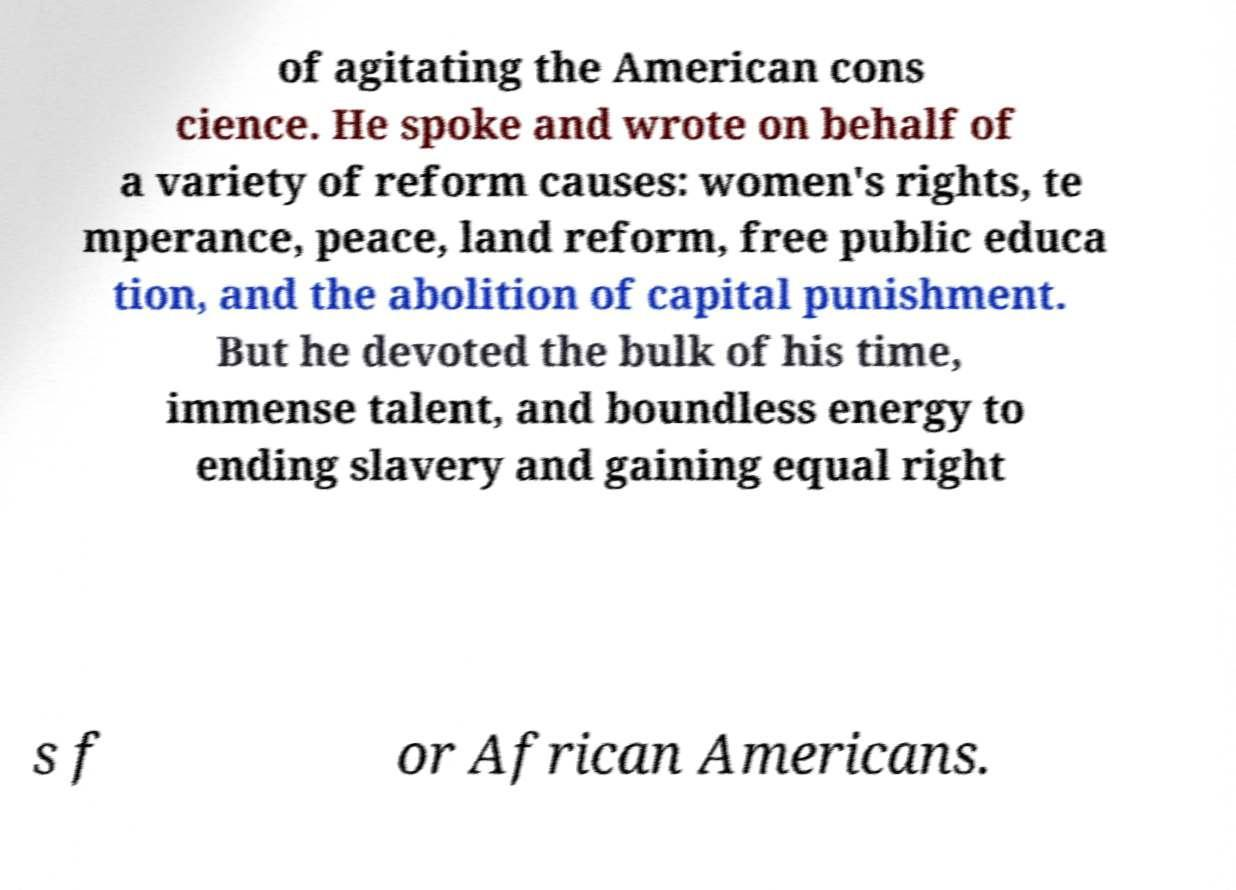Could you extract and type out the text from this image? of agitating the American cons cience. He spoke and wrote on behalf of a variety of reform causes: women's rights, te mperance, peace, land reform, free public educa tion, and the abolition of capital punishment. But he devoted the bulk of his time, immense talent, and boundless energy to ending slavery and gaining equal right s f or African Americans. 